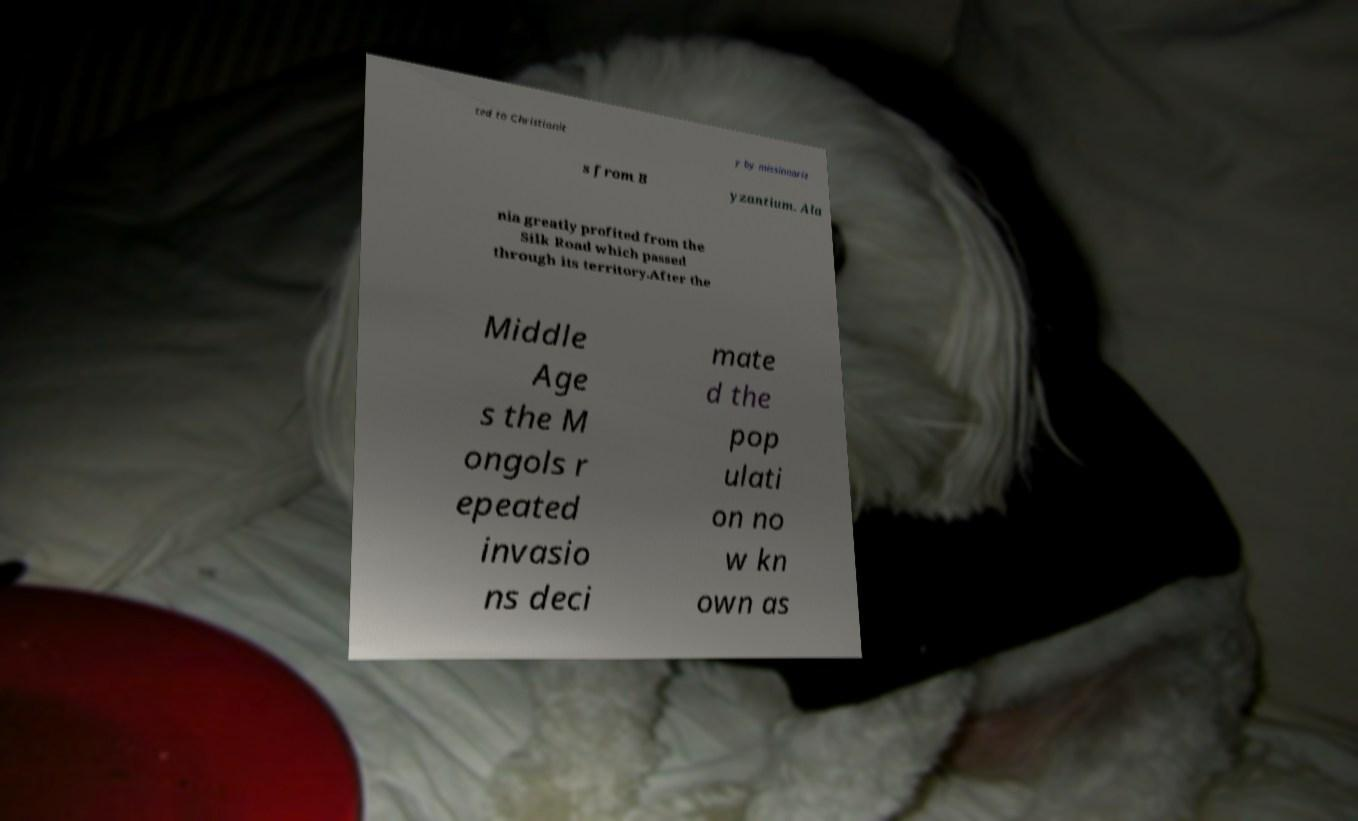There's text embedded in this image that I need extracted. Can you transcribe it verbatim? ted to Christianit y by missionarie s from B yzantium. Ala nia greatly profited from the Silk Road which passed through its territory.After the Middle Age s the M ongols r epeated invasio ns deci mate d the pop ulati on no w kn own as 